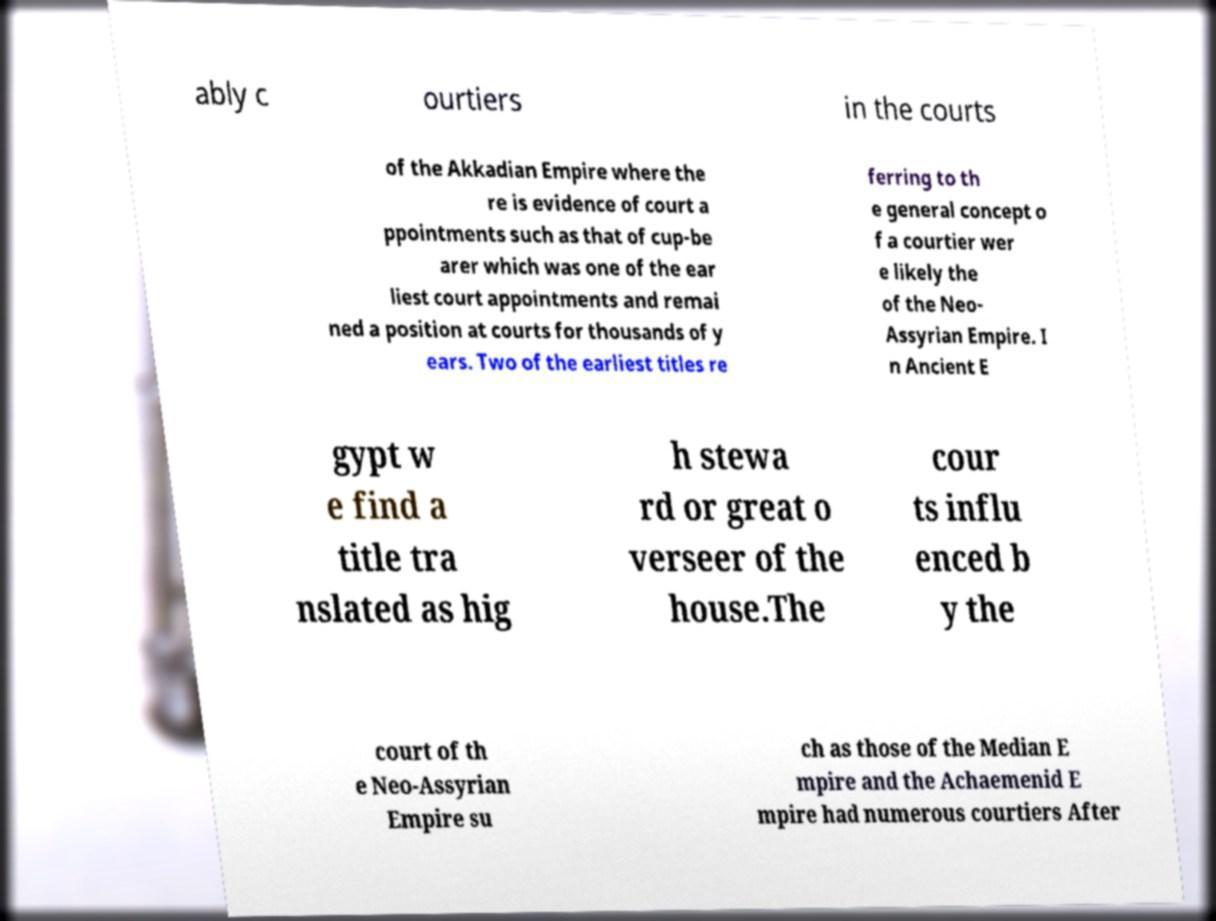Could you assist in decoding the text presented in this image and type it out clearly? ably c ourtiers in the courts of the Akkadian Empire where the re is evidence of court a ppointments such as that of cup-be arer which was one of the ear liest court appointments and remai ned a position at courts for thousands of y ears. Two of the earliest titles re ferring to th e general concept o f a courtier wer e likely the of the Neo- Assyrian Empire. I n Ancient E gypt w e find a title tra nslated as hig h stewa rd or great o verseer of the house.The cour ts influ enced b y the court of th e Neo-Assyrian Empire su ch as those of the Median E mpire and the Achaemenid E mpire had numerous courtiers After 